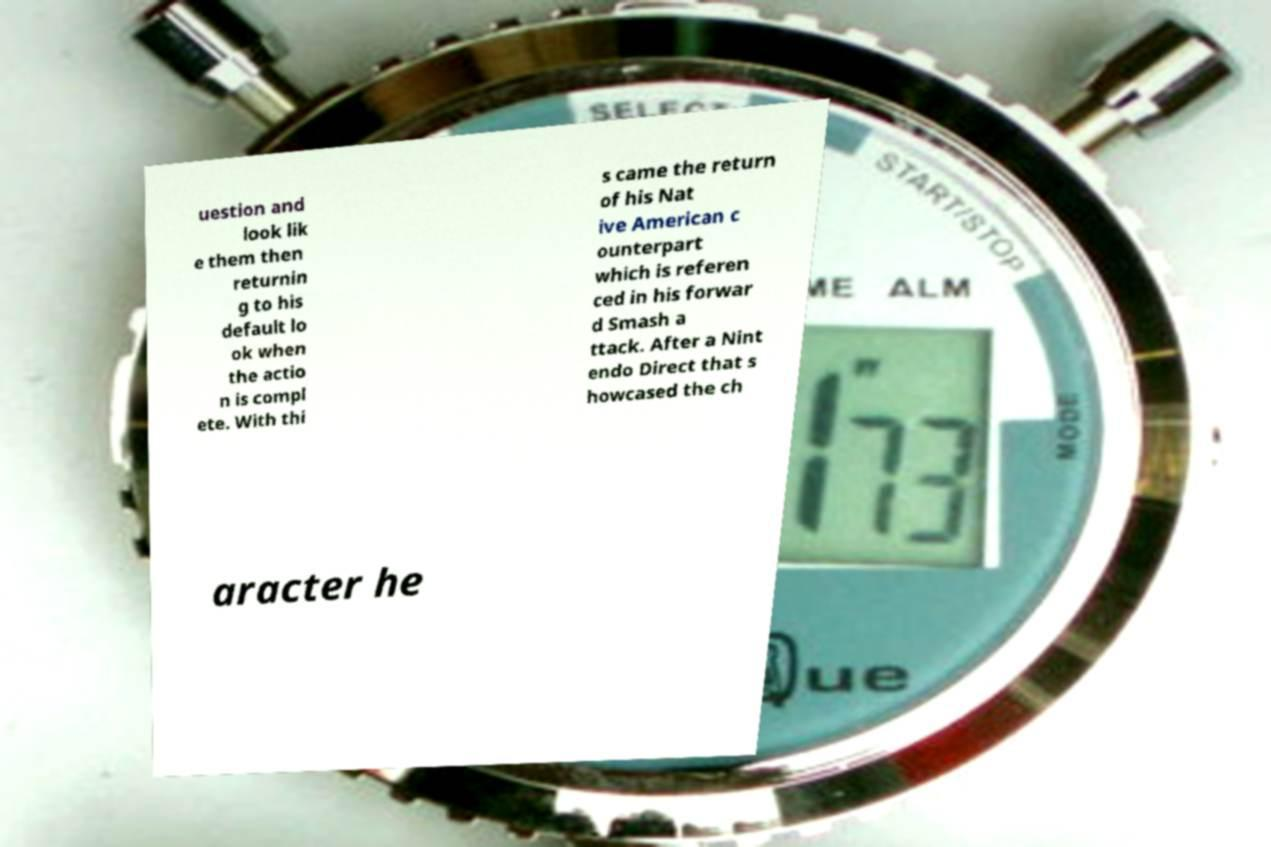I need the written content from this picture converted into text. Can you do that? uestion and look lik e them then returnin g to his default lo ok when the actio n is compl ete. With thi s came the return of his Nat ive American c ounterpart which is referen ced in his forwar d Smash a ttack. After a Nint endo Direct that s howcased the ch aracter he 